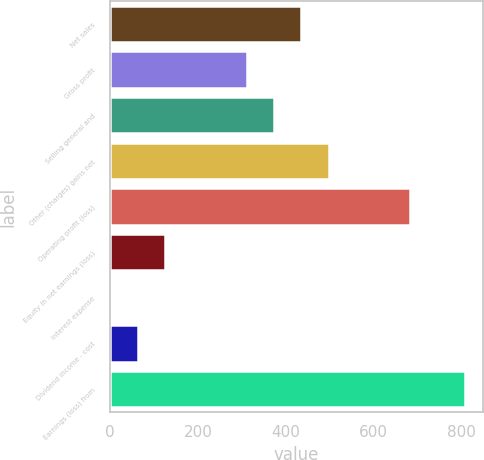<chart> <loc_0><loc_0><loc_500><loc_500><bar_chart><fcel>Net sales<fcel>Gross profit<fcel>Selling general and<fcel>Other (charges) gains net<fcel>Operating profit (loss)<fcel>Equity in net earnings (loss)<fcel>Interest expense<fcel>Dividend income - cost<fcel>Earnings (loss) from<nl><fcel>435<fcel>311<fcel>373<fcel>497<fcel>683<fcel>125<fcel>1<fcel>63<fcel>807<nl></chart> 